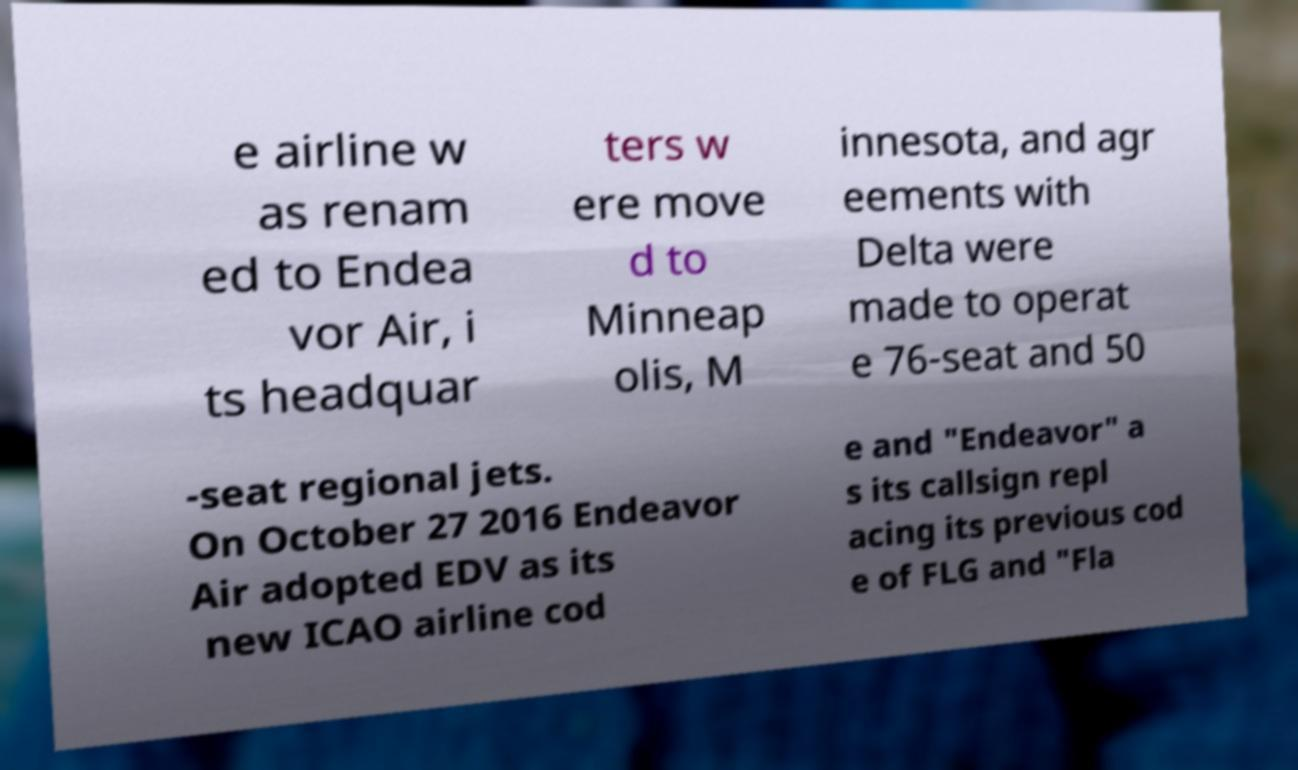For documentation purposes, I need the text within this image transcribed. Could you provide that? e airline w as renam ed to Endea vor Air, i ts headquar ters w ere move d to Minneap olis, M innesota, and agr eements with Delta were made to operat e 76-seat and 50 -seat regional jets. On October 27 2016 Endeavor Air adopted EDV as its new ICAO airline cod e and "Endeavor" a s its callsign repl acing its previous cod e of FLG and "Fla 